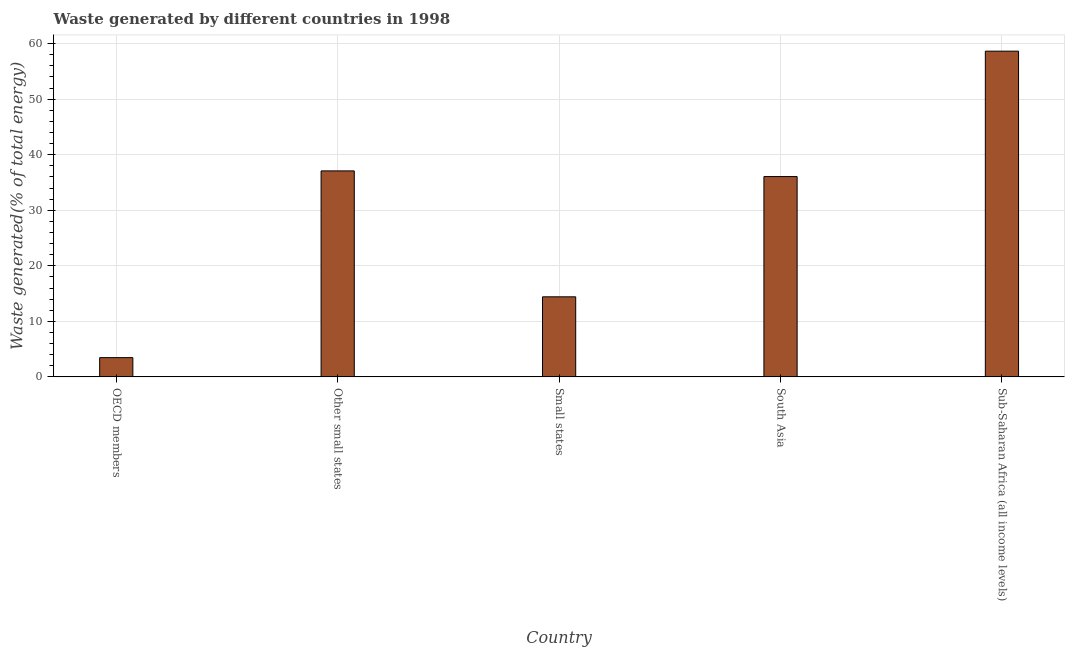Does the graph contain any zero values?
Provide a succinct answer. No. What is the title of the graph?
Provide a short and direct response. Waste generated by different countries in 1998. What is the label or title of the X-axis?
Your response must be concise. Country. What is the label or title of the Y-axis?
Ensure brevity in your answer.  Waste generated(% of total energy). What is the amount of waste generated in Small states?
Your answer should be compact. 14.41. Across all countries, what is the maximum amount of waste generated?
Ensure brevity in your answer.  58.65. Across all countries, what is the minimum amount of waste generated?
Offer a very short reply. 3.46. In which country was the amount of waste generated maximum?
Provide a short and direct response. Sub-Saharan Africa (all income levels). In which country was the amount of waste generated minimum?
Offer a terse response. OECD members. What is the sum of the amount of waste generated?
Make the answer very short. 149.68. What is the difference between the amount of waste generated in South Asia and Sub-Saharan Africa (all income levels)?
Offer a very short reply. -22.58. What is the average amount of waste generated per country?
Your answer should be compact. 29.94. What is the median amount of waste generated?
Provide a succinct answer. 36.06. In how many countries, is the amount of waste generated greater than 22 %?
Keep it short and to the point. 3. What is the ratio of the amount of waste generated in Other small states to that in South Asia?
Ensure brevity in your answer.  1.03. Is the amount of waste generated in OECD members less than that in South Asia?
Offer a very short reply. Yes. Is the difference between the amount of waste generated in Other small states and Sub-Saharan Africa (all income levels) greater than the difference between any two countries?
Provide a short and direct response. No. What is the difference between the highest and the second highest amount of waste generated?
Your answer should be very brief. 21.56. Is the sum of the amount of waste generated in OECD members and South Asia greater than the maximum amount of waste generated across all countries?
Your response must be concise. No. What is the difference between the highest and the lowest amount of waste generated?
Make the answer very short. 55.18. In how many countries, is the amount of waste generated greater than the average amount of waste generated taken over all countries?
Offer a terse response. 3. How many bars are there?
Offer a very short reply. 5. Are all the bars in the graph horizontal?
Keep it short and to the point. No. How many countries are there in the graph?
Give a very brief answer. 5. What is the Waste generated(% of total energy) of OECD members?
Offer a terse response. 3.46. What is the Waste generated(% of total energy) in Other small states?
Provide a succinct answer. 37.09. What is the Waste generated(% of total energy) of Small states?
Make the answer very short. 14.41. What is the Waste generated(% of total energy) in South Asia?
Ensure brevity in your answer.  36.06. What is the Waste generated(% of total energy) of Sub-Saharan Africa (all income levels)?
Make the answer very short. 58.65. What is the difference between the Waste generated(% of total energy) in OECD members and Other small states?
Provide a short and direct response. -33.62. What is the difference between the Waste generated(% of total energy) in OECD members and Small states?
Your answer should be compact. -10.95. What is the difference between the Waste generated(% of total energy) in OECD members and South Asia?
Your answer should be very brief. -32.6. What is the difference between the Waste generated(% of total energy) in OECD members and Sub-Saharan Africa (all income levels)?
Ensure brevity in your answer.  -55.18. What is the difference between the Waste generated(% of total energy) in Other small states and Small states?
Make the answer very short. 22.67. What is the difference between the Waste generated(% of total energy) in Other small states and South Asia?
Offer a very short reply. 1.02. What is the difference between the Waste generated(% of total energy) in Other small states and Sub-Saharan Africa (all income levels)?
Provide a short and direct response. -21.56. What is the difference between the Waste generated(% of total energy) in Small states and South Asia?
Your answer should be very brief. -21.65. What is the difference between the Waste generated(% of total energy) in Small states and Sub-Saharan Africa (all income levels)?
Your response must be concise. -44.23. What is the difference between the Waste generated(% of total energy) in South Asia and Sub-Saharan Africa (all income levels)?
Make the answer very short. -22.58. What is the ratio of the Waste generated(% of total energy) in OECD members to that in Other small states?
Provide a short and direct response. 0.09. What is the ratio of the Waste generated(% of total energy) in OECD members to that in Small states?
Give a very brief answer. 0.24. What is the ratio of the Waste generated(% of total energy) in OECD members to that in South Asia?
Provide a short and direct response. 0.1. What is the ratio of the Waste generated(% of total energy) in OECD members to that in Sub-Saharan Africa (all income levels)?
Provide a succinct answer. 0.06. What is the ratio of the Waste generated(% of total energy) in Other small states to that in Small states?
Ensure brevity in your answer.  2.57. What is the ratio of the Waste generated(% of total energy) in Other small states to that in South Asia?
Make the answer very short. 1.03. What is the ratio of the Waste generated(% of total energy) in Other small states to that in Sub-Saharan Africa (all income levels)?
Provide a succinct answer. 0.63. What is the ratio of the Waste generated(% of total energy) in Small states to that in South Asia?
Provide a succinct answer. 0.4. What is the ratio of the Waste generated(% of total energy) in Small states to that in Sub-Saharan Africa (all income levels)?
Provide a succinct answer. 0.25. What is the ratio of the Waste generated(% of total energy) in South Asia to that in Sub-Saharan Africa (all income levels)?
Provide a short and direct response. 0.61. 